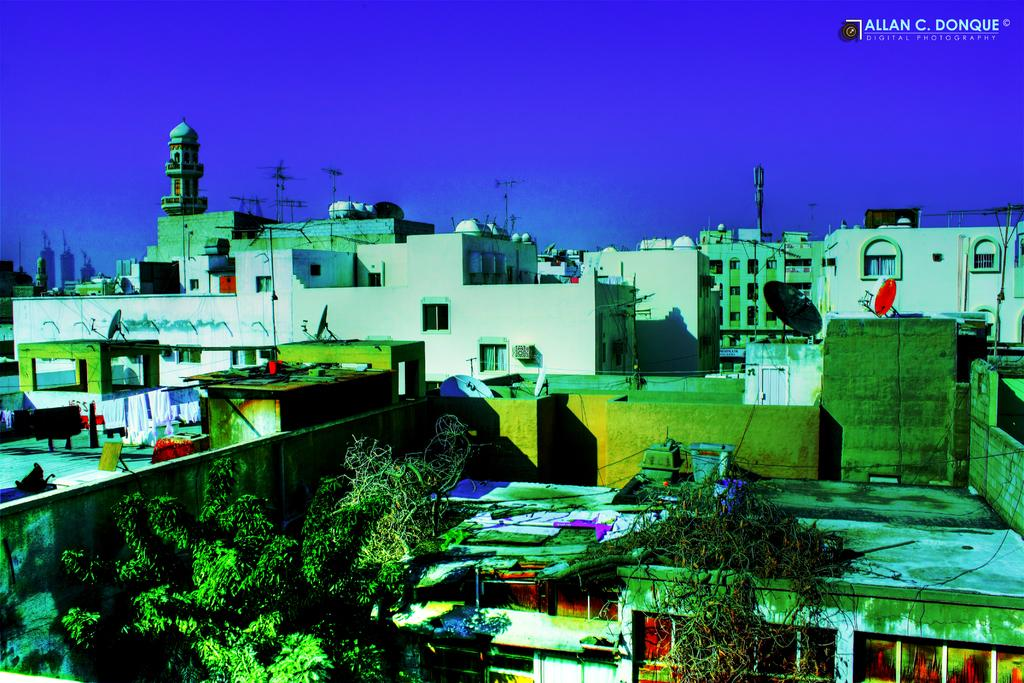What is located in the foreground of the image? There are trees in the foreground of the image. What can be seen behind the trees in the image? There are buildings visible behind the trees in the image. What type of behavior can be observed in the pies in the image? There are no pies present in the image, so it is not possible to observe any behavior. 